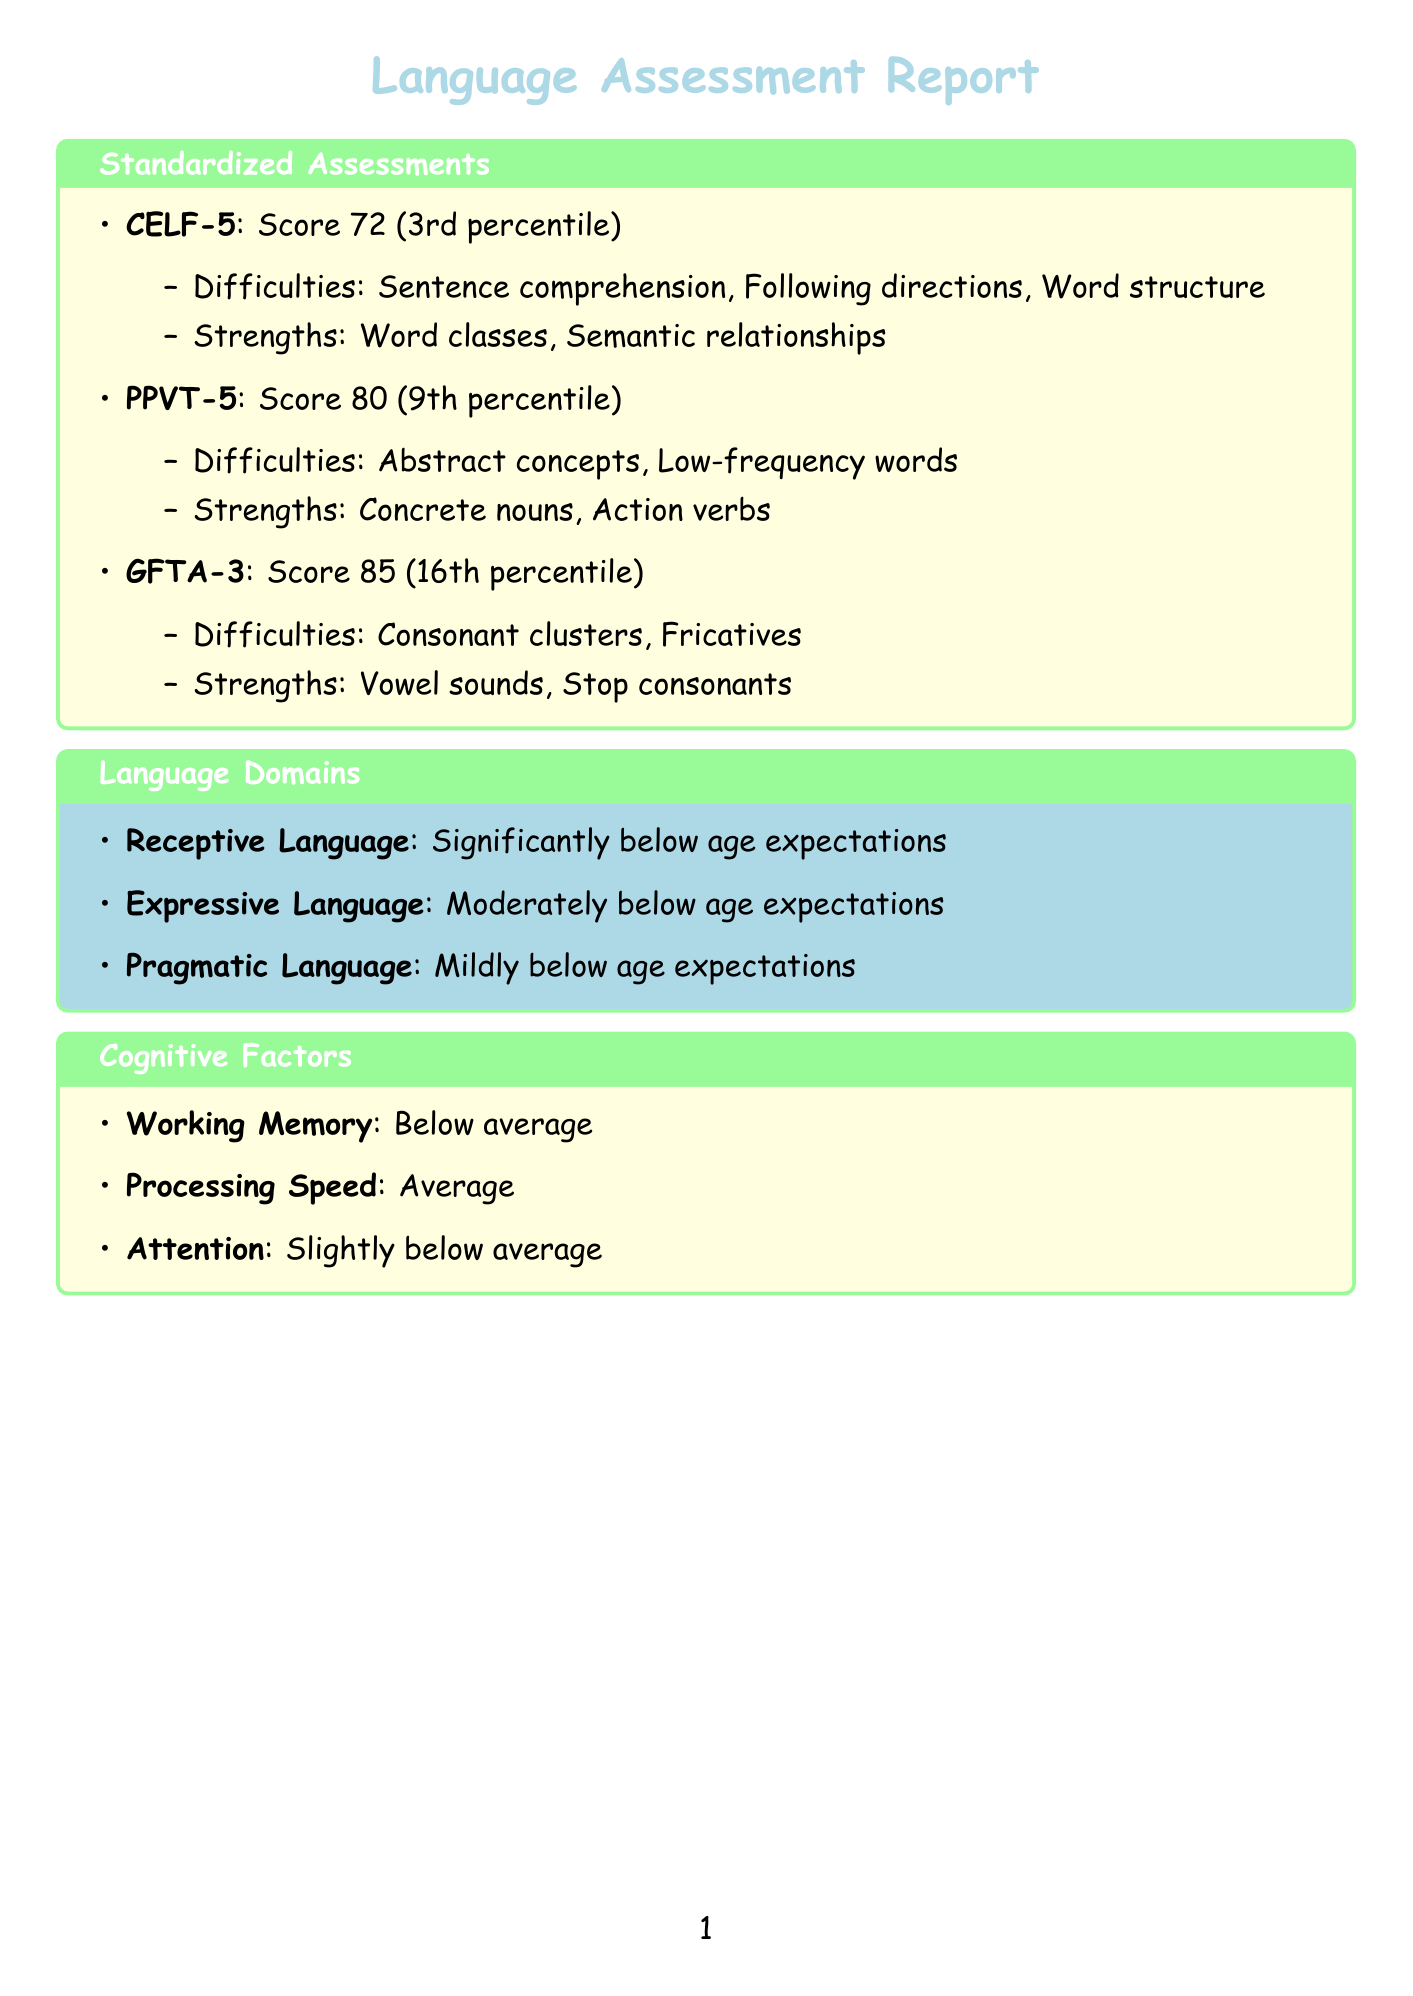What is the score for CELF-5? The document specifies the child's score on the CELF-5 assessment as 72.
Answer: 72 What percentile does the child score in the Peabody Picture Vocabulary Test? The document indicates that the child's percentile ranking for the PPVT-5 is 9.
Answer: 9 What are two areas of difficulty identified in the child's CELF-5 assessment? The document lists "Sentence comprehension" and "Following directions" as difficulties for CELF-5.
Answer: Sentence comprehension, Following directions Which domains of language does the child perform moderately below age expectations? The document states the child's performance is moderately below age expectations in Expressive Language.
Answer: Expressive Language What is the child's performance in Working Memory? According to the document, the child's performance in Working Memory is below average.
Answer: Below average What kind of strategies are recommended for Vocabulary Development? The document suggests using visual aids and graphic organizers as a strategy for Vocabulary Development.
Answer: Visual aids and graphic organizers What is the general impact of the child's Attention on language tasks? The document mentions that the child's Attention leads to occasional difficulty sustaining attention, affecting comprehension and learning.
Answer: Occasional difficulty Which assessment indicates the area of strength as Action verbs? The document specifies that the PPVT-5 indicates the area of strength as Action verbs.
Answer: PPVT-5 